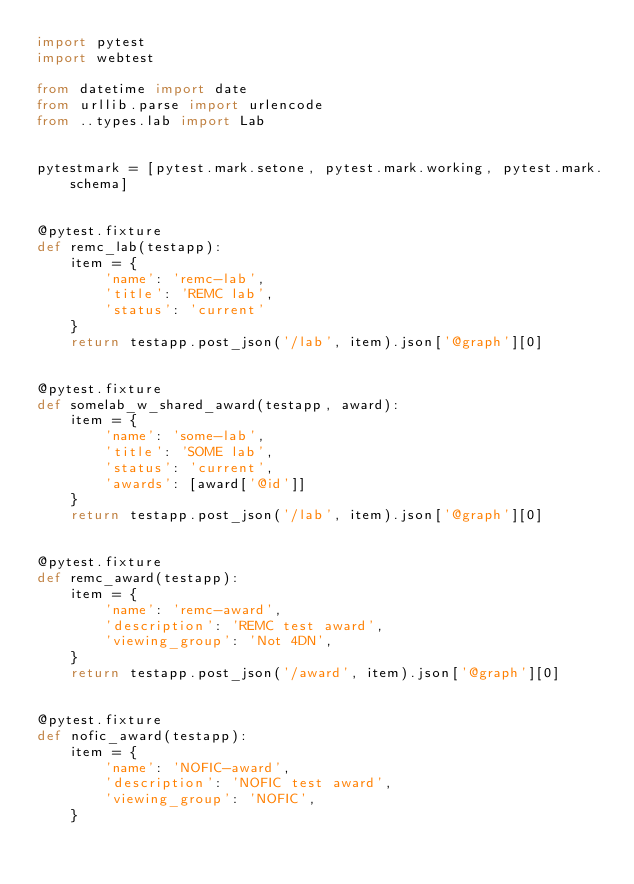<code> <loc_0><loc_0><loc_500><loc_500><_Python_>import pytest
import webtest

from datetime import date
from urllib.parse import urlencode
from ..types.lab import Lab


pytestmark = [pytest.mark.setone, pytest.mark.working, pytest.mark.schema]


@pytest.fixture
def remc_lab(testapp):
    item = {
        'name': 'remc-lab',
        'title': 'REMC lab',
        'status': 'current'
    }
    return testapp.post_json('/lab', item).json['@graph'][0]


@pytest.fixture
def somelab_w_shared_award(testapp, award):
    item = {
        'name': 'some-lab',
        'title': 'SOME lab',
        'status': 'current',
        'awards': [award['@id']]
    }
    return testapp.post_json('/lab', item).json['@graph'][0]


@pytest.fixture
def remc_award(testapp):
    item = {
        'name': 'remc-award',
        'description': 'REMC test award',
        'viewing_group': 'Not 4DN',
    }
    return testapp.post_json('/award', item).json['@graph'][0]


@pytest.fixture
def nofic_award(testapp):
    item = {
        'name': 'NOFIC-award',
        'description': 'NOFIC test award',
        'viewing_group': 'NOFIC',
    }</code> 